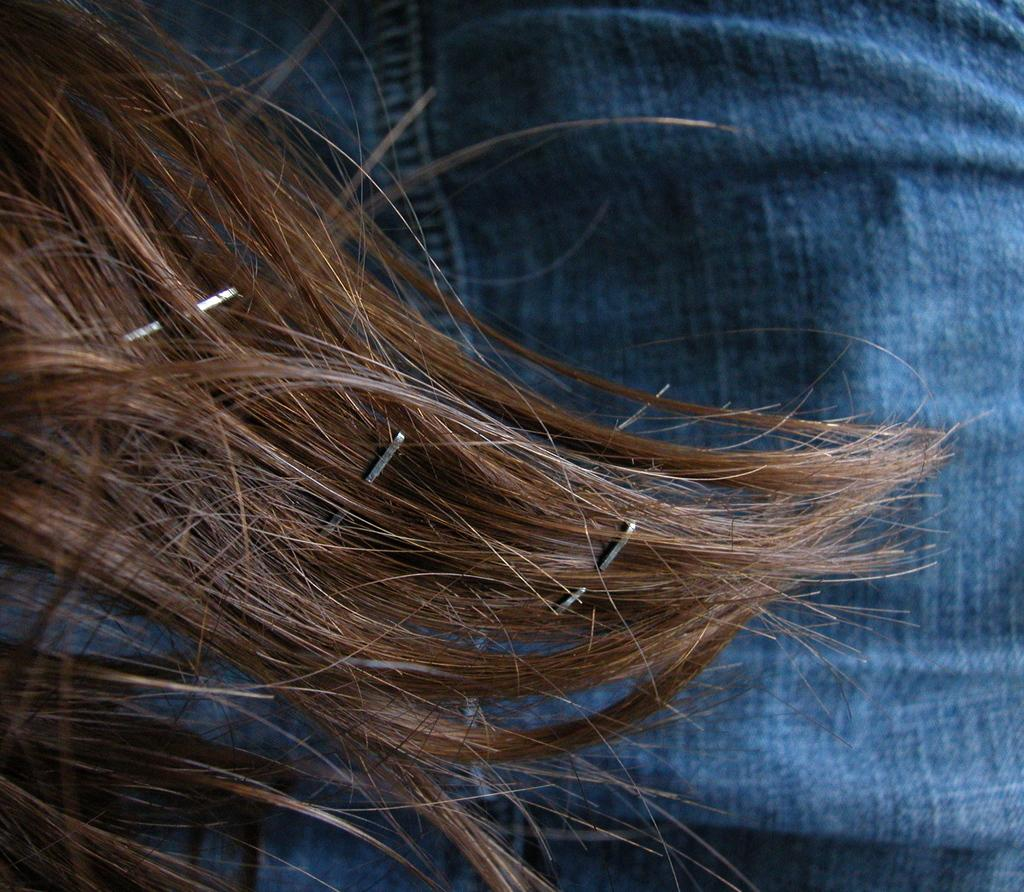What is located in the foreground of the image? There are hair in the foreground of the image. What is visible in the background of the image? There is a jeans in the background of the image. What type of smoke can be seen coming from the jeans in the image? There is no smoke present in the image; it features hair in the foreground and jeans in the background. Can you describe the beetle that is crawling on the jeans in the image? There is no beetle present in the image; it only features hair in the foreground and jeans in the background. 